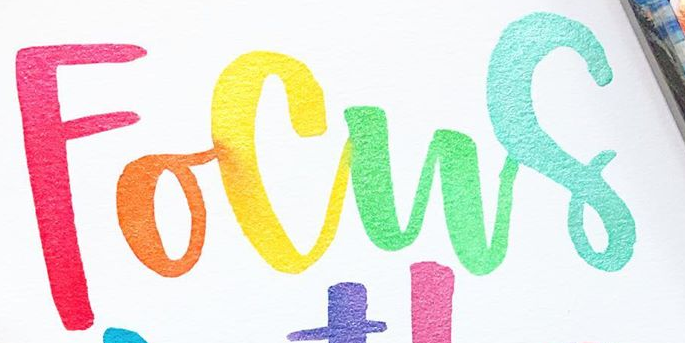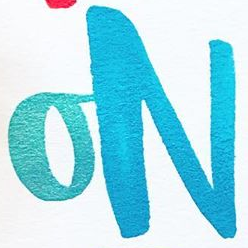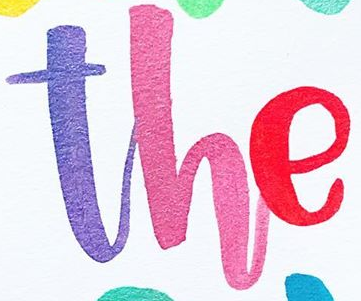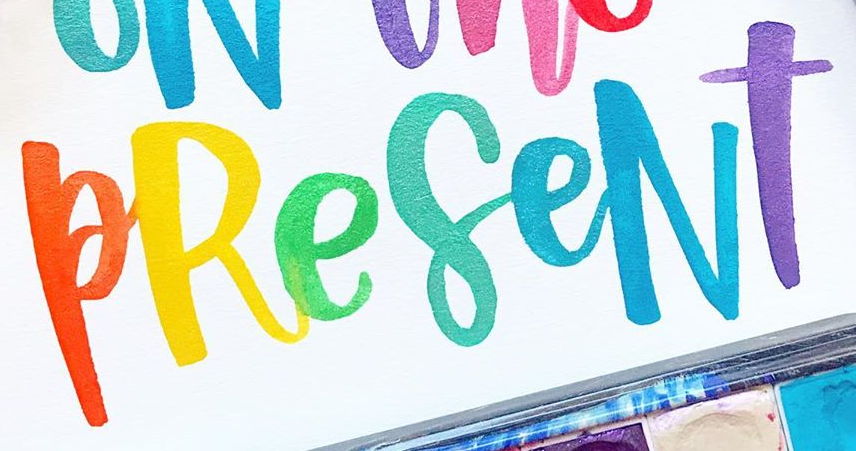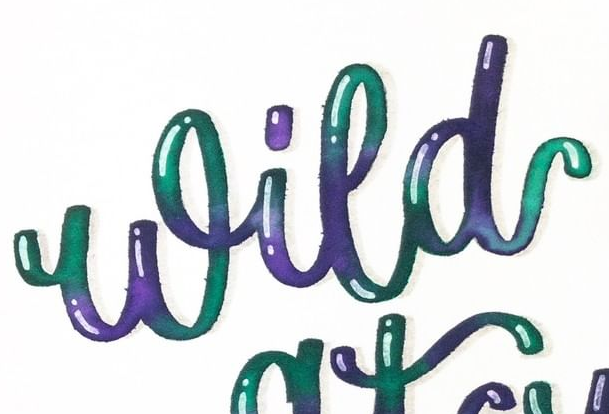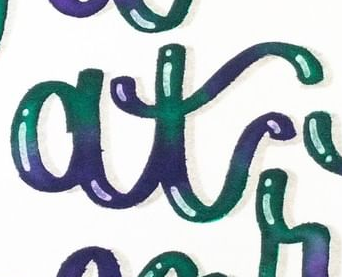What text appears in these images from left to right, separated by a semicolon? Focus; ON; The; PReseNT; Wild; at 